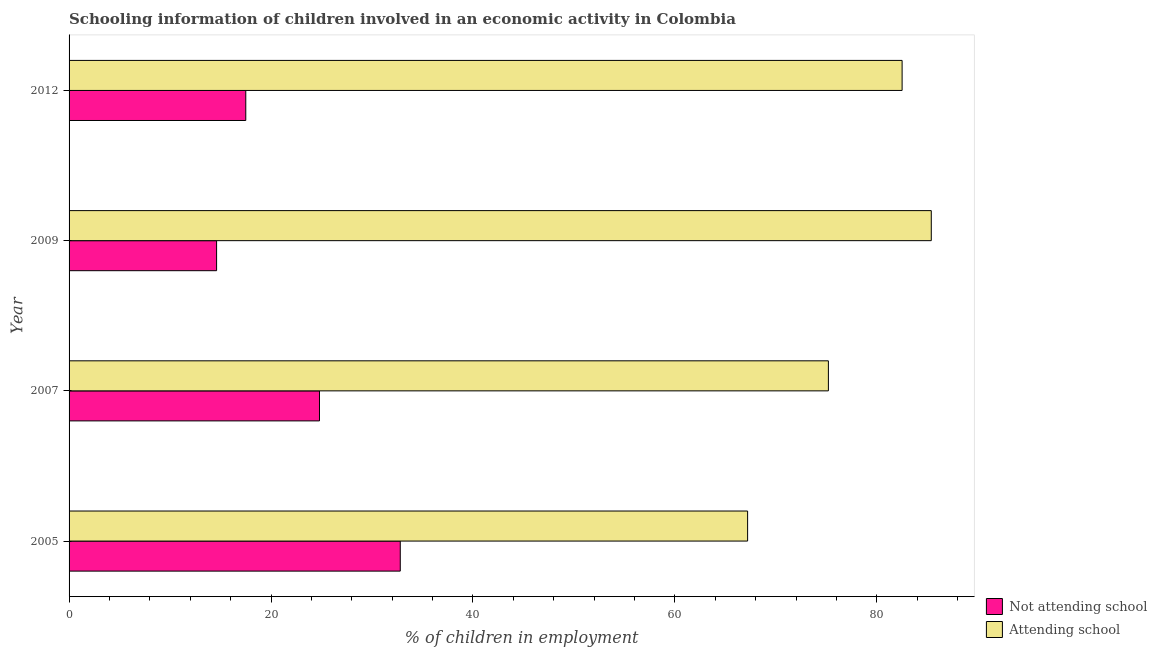How many different coloured bars are there?
Keep it short and to the point. 2. How many groups of bars are there?
Your response must be concise. 4. How many bars are there on the 3rd tick from the top?
Your response must be concise. 2. What is the label of the 3rd group of bars from the top?
Your answer should be very brief. 2007. What is the percentage of employed children who are attending school in 2005?
Make the answer very short. 67.2. Across all years, what is the maximum percentage of employed children who are not attending school?
Your answer should be compact. 32.8. Across all years, what is the minimum percentage of employed children who are attending school?
Make the answer very short. 67.2. In which year was the percentage of employed children who are not attending school minimum?
Keep it short and to the point. 2009. What is the total percentage of employed children who are attending school in the graph?
Your answer should be very brief. 310.29. What is the difference between the percentage of employed children who are attending school in 2009 and the percentage of employed children who are not attending school in 2007?
Offer a very short reply. 60.59. What is the average percentage of employed children who are not attending school per year?
Your answer should be compact. 22.43. In the year 2009, what is the difference between the percentage of employed children who are attending school and percentage of employed children who are not attending school?
Make the answer very short. 70.78. What is the ratio of the percentage of employed children who are attending school in 2005 to that in 2012?
Make the answer very short. 0.81. Is the percentage of employed children who are not attending school in 2007 less than that in 2009?
Your answer should be very brief. No. Is the difference between the percentage of employed children who are not attending school in 2005 and 2007 greater than the difference between the percentage of employed children who are attending school in 2005 and 2007?
Your answer should be compact. Yes. What is the difference between the highest and the second highest percentage of employed children who are attending school?
Your answer should be very brief. 2.89. What is the difference between the highest and the lowest percentage of employed children who are not attending school?
Ensure brevity in your answer.  18.19. In how many years, is the percentage of employed children who are attending school greater than the average percentage of employed children who are attending school taken over all years?
Make the answer very short. 2. What does the 1st bar from the top in 2005 represents?
Your answer should be very brief. Attending school. What does the 2nd bar from the bottom in 2009 represents?
Offer a terse response. Attending school. How many bars are there?
Your answer should be very brief. 8. How many years are there in the graph?
Provide a short and direct response. 4. Does the graph contain any zero values?
Offer a terse response. No. How many legend labels are there?
Provide a succinct answer. 2. How are the legend labels stacked?
Give a very brief answer. Vertical. What is the title of the graph?
Offer a terse response. Schooling information of children involved in an economic activity in Colombia. What is the label or title of the X-axis?
Offer a very short reply. % of children in employment. What is the % of children in employment in Not attending school in 2005?
Offer a terse response. 32.8. What is the % of children in employment in Attending school in 2005?
Offer a very short reply. 67.2. What is the % of children in employment in Not attending school in 2007?
Provide a succinct answer. 24.8. What is the % of children in employment of Attending school in 2007?
Keep it short and to the point. 75.2. What is the % of children in employment of Not attending school in 2009?
Make the answer very short. 14.61. What is the % of children in employment in Attending school in 2009?
Your response must be concise. 85.39. What is the % of children in employment of Attending school in 2012?
Give a very brief answer. 82.5. Across all years, what is the maximum % of children in employment in Not attending school?
Give a very brief answer. 32.8. Across all years, what is the maximum % of children in employment of Attending school?
Your answer should be compact. 85.39. Across all years, what is the minimum % of children in employment of Not attending school?
Keep it short and to the point. 14.61. Across all years, what is the minimum % of children in employment in Attending school?
Your answer should be very brief. 67.2. What is the total % of children in employment of Not attending school in the graph?
Your answer should be compact. 89.71. What is the total % of children in employment in Attending school in the graph?
Your answer should be very brief. 310.29. What is the difference between the % of children in employment in Not attending school in 2005 and that in 2009?
Your answer should be very brief. 18.19. What is the difference between the % of children in employment in Attending school in 2005 and that in 2009?
Provide a succinct answer. -18.19. What is the difference between the % of children in employment of Not attending school in 2005 and that in 2012?
Your response must be concise. 15.3. What is the difference between the % of children in employment in Attending school in 2005 and that in 2012?
Give a very brief answer. -15.3. What is the difference between the % of children in employment of Not attending school in 2007 and that in 2009?
Ensure brevity in your answer.  10.19. What is the difference between the % of children in employment of Attending school in 2007 and that in 2009?
Your answer should be very brief. -10.19. What is the difference between the % of children in employment in Not attending school in 2007 and that in 2012?
Your answer should be compact. 7.3. What is the difference between the % of children in employment in Not attending school in 2009 and that in 2012?
Your response must be concise. -2.89. What is the difference between the % of children in employment in Attending school in 2009 and that in 2012?
Provide a short and direct response. 2.89. What is the difference between the % of children in employment of Not attending school in 2005 and the % of children in employment of Attending school in 2007?
Your answer should be very brief. -42.4. What is the difference between the % of children in employment in Not attending school in 2005 and the % of children in employment in Attending school in 2009?
Keep it short and to the point. -52.59. What is the difference between the % of children in employment in Not attending school in 2005 and the % of children in employment in Attending school in 2012?
Provide a short and direct response. -49.7. What is the difference between the % of children in employment in Not attending school in 2007 and the % of children in employment in Attending school in 2009?
Make the answer very short. -60.59. What is the difference between the % of children in employment in Not attending school in 2007 and the % of children in employment in Attending school in 2012?
Offer a very short reply. -57.7. What is the difference between the % of children in employment of Not attending school in 2009 and the % of children in employment of Attending school in 2012?
Offer a terse response. -67.89. What is the average % of children in employment in Not attending school per year?
Ensure brevity in your answer.  22.43. What is the average % of children in employment in Attending school per year?
Offer a very short reply. 77.57. In the year 2005, what is the difference between the % of children in employment of Not attending school and % of children in employment of Attending school?
Make the answer very short. -34.4. In the year 2007, what is the difference between the % of children in employment in Not attending school and % of children in employment in Attending school?
Provide a succinct answer. -50.4. In the year 2009, what is the difference between the % of children in employment of Not attending school and % of children in employment of Attending school?
Your answer should be very brief. -70.78. In the year 2012, what is the difference between the % of children in employment of Not attending school and % of children in employment of Attending school?
Ensure brevity in your answer.  -65. What is the ratio of the % of children in employment of Not attending school in 2005 to that in 2007?
Offer a terse response. 1.32. What is the ratio of the % of children in employment of Attending school in 2005 to that in 2007?
Your answer should be very brief. 0.89. What is the ratio of the % of children in employment in Not attending school in 2005 to that in 2009?
Offer a very short reply. 2.25. What is the ratio of the % of children in employment of Attending school in 2005 to that in 2009?
Your answer should be compact. 0.79. What is the ratio of the % of children in employment of Not attending school in 2005 to that in 2012?
Make the answer very short. 1.87. What is the ratio of the % of children in employment of Attending school in 2005 to that in 2012?
Ensure brevity in your answer.  0.81. What is the ratio of the % of children in employment of Not attending school in 2007 to that in 2009?
Give a very brief answer. 1.7. What is the ratio of the % of children in employment in Attending school in 2007 to that in 2009?
Offer a terse response. 0.88. What is the ratio of the % of children in employment in Not attending school in 2007 to that in 2012?
Keep it short and to the point. 1.42. What is the ratio of the % of children in employment in Attending school in 2007 to that in 2012?
Provide a succinct answer. 0.91. What is the ratio of the % of children in employment of Not attending school in 2009 to that in 2012?
Provide a succinct answer. 0.83. What is the ratio of the % of children in employment of Attending school in 2009 to that in 2012?
Keep it short and to the point. 1.03. What is the difference between the highest and the second highest % of children in employment in Attending school?
Keep it short and to the point. 2.89. What is the difference between the highest and the lowest % of children in employment in Not attending school?
Your answer should be very brief. 18.19. What is the difference between the highest and the lowest % of children in employment of Attending school?
Your answer should be compact. 18.19. 